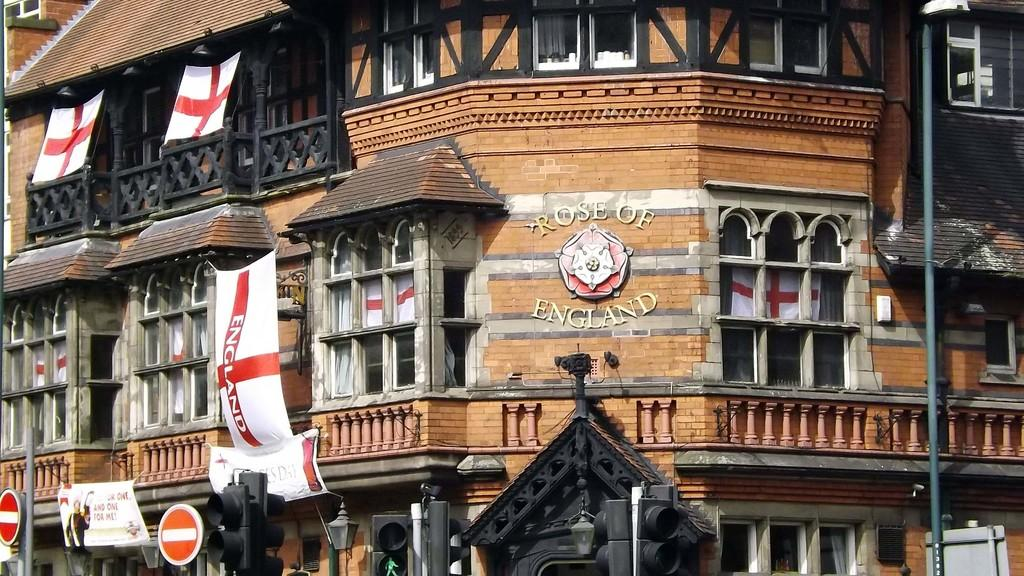Provide a one-sentence caption for the provided image. Brown building with "Rose of England" in the front. 